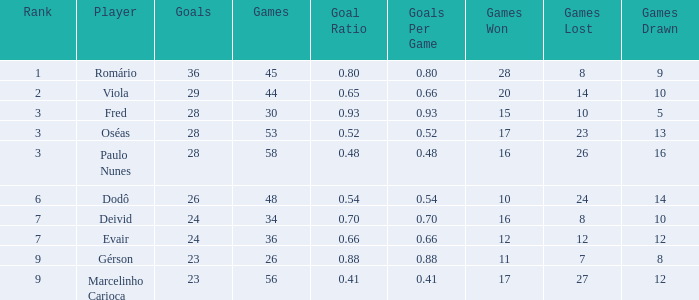How many goal ratios have rank of 2 with more than 44 games? 0.0. Would you be able to parse every entry in this table? {'header': ['Rank', 'Player', 'Goals', 'Games', 'Goal Ratio', 'Goals Per Game', 'Games Won', 'Games Lost', 'Games Drawn'], 'rows': [['1', 'Romário', '36', '45', '0.80', '0.80', '28', '8', '9'], ['2', 'Viola', '29', '44', '0.65', '0.66', '20', '14', '10'], ['3', 'Fred', '28', '30', '0.93', '0.93', '15', '10', '5'], ['3', 'Oséas', '28', '53', '0.52', '0.52', '17', '23', '13'], ['3', 'Paulo Nunes', '28', '58', '0.48', '0.48', '16', '26', '16'], ['6', 'Dodô', '26', '48', '0.54', '0.54', '10', '24', '14'], ['7', 'Deivid', '24', '34', '0.70', '0.70', '16', '8', '10'], ['7', 'Evair', '24', '36', '0.66', '0.66', '12', '12', '12'], ['9', 'Gérson', '23', '26', '0.88', '0.88', '11', '7', '8'], ['9', 'Marcelinho Carioca', '23', '56', '0.41', '0.41', '17', '27', '12']]} 